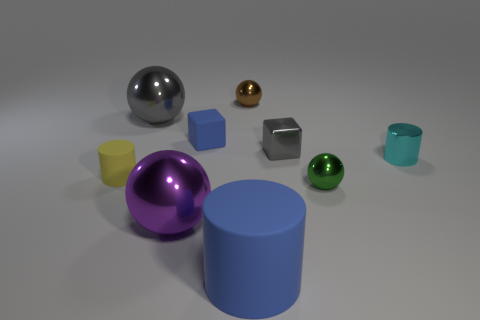Subtract 1 blocks. How many blocks are left? 1 Subtract all small green spheres. How many spheres are left? 3 Subtract all blocks. How many objects are left? 7 Subtract all purple spheres. How many spheres are left? 3 Subtract all cyan balls. How many cyan cylinders are left? 1 Subtract all small blue cylinders. Subtract all gray shiny spheres. How many objects are left? 8 Add 7 brown objects. How many brown objects are left? 8 Add 6 large cyan rubber objects. How many large cyan rubber objects exist? 6 Subtract 0 cyan balls. How many objects are left? 9 Subtract all yellow cubes. Subtract all brown spheres. How many cubes are left? 2 